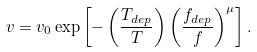<formula> <loc_0><loc_0><loc_500><loc_500>v = v _ { 0 } \exp \left [ - \left ( \frac { T _ { d e p } } { T } \right ) \left ( \frac { f _ { d e p } } { f } \right ) ^ { \mu } \right ] .</formula> 